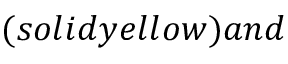Convert formula to latex. <formula><loc_0><loc_0><loc_500><loc_500>( s o l i d y e l l o w ) a n d</formula> 